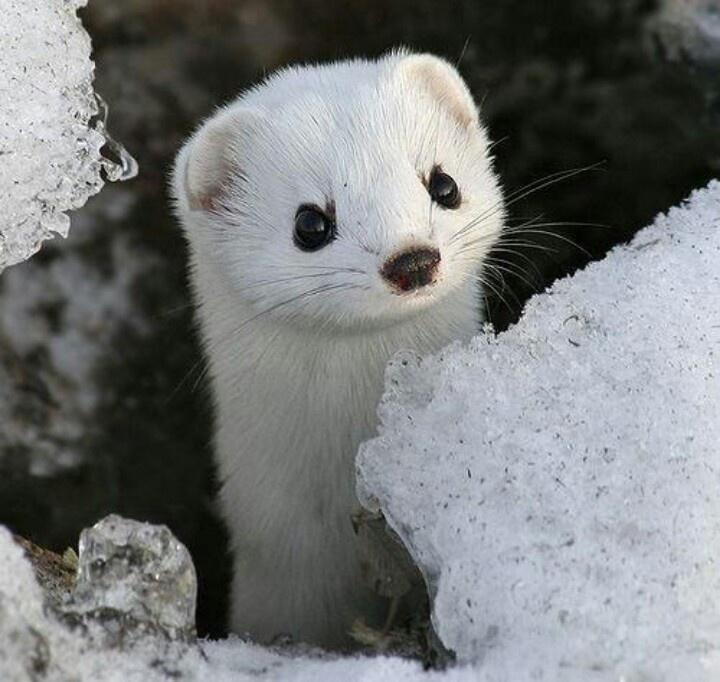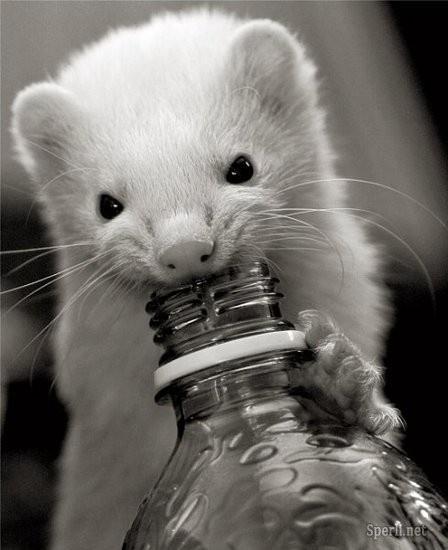The first image is the image on the left, the second image is the image on the right. Considering the images on both sides, is "One ferret is on a rock." valid? Answer yes or no. No. The first image is the image on the left, the second image is the image on the right. Given the left and right images, does the statement "Each image shows a single forward-turned ferret, and at least one ferret has solid-white fur." hold true? Answer yes or no. Yes. 